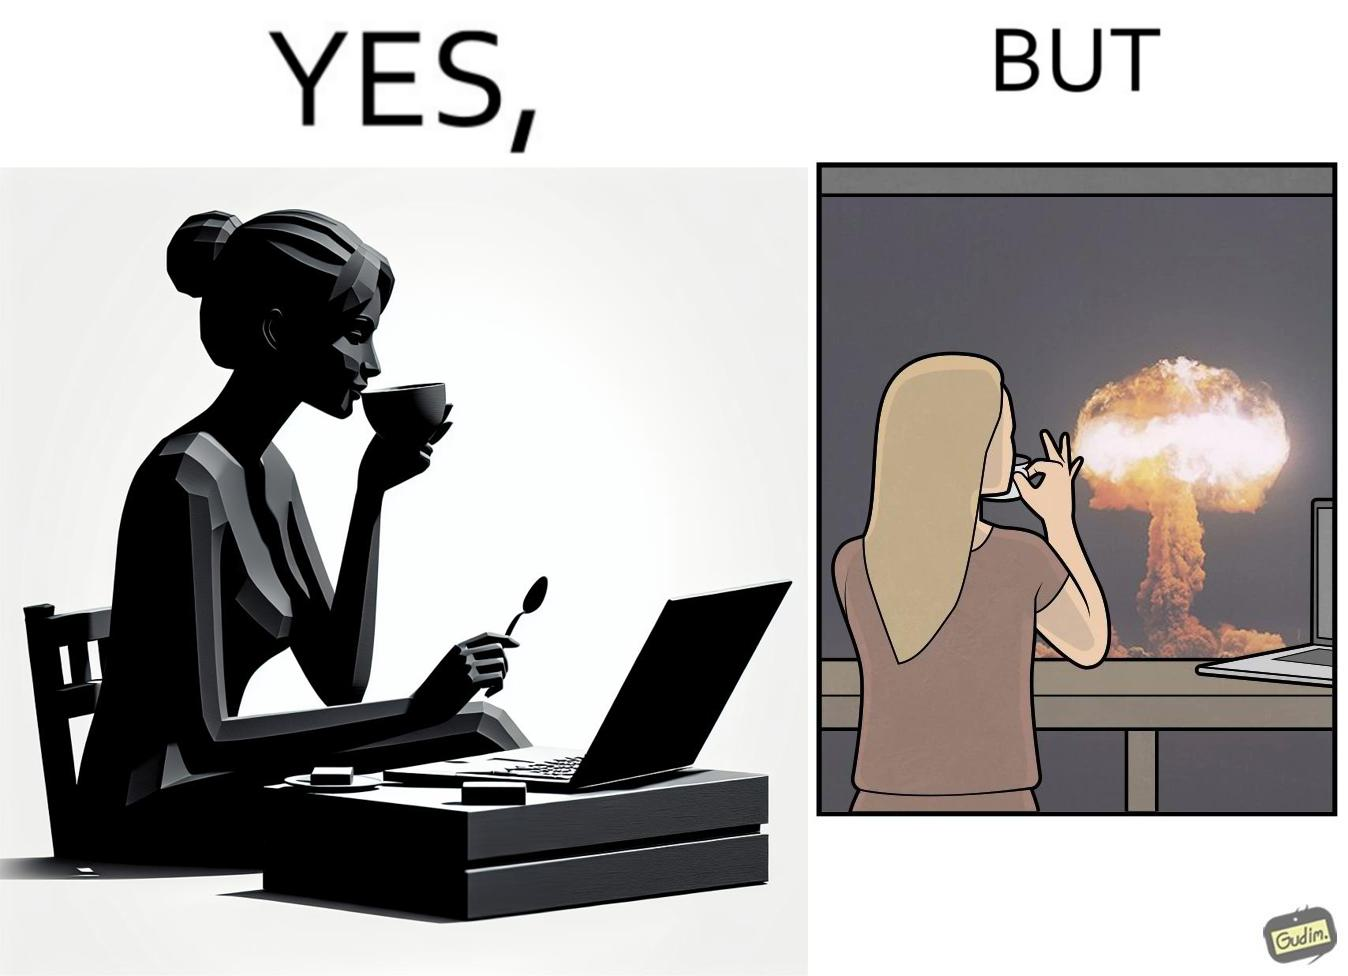Is this a satirical image? Yes, this image is satirical. 